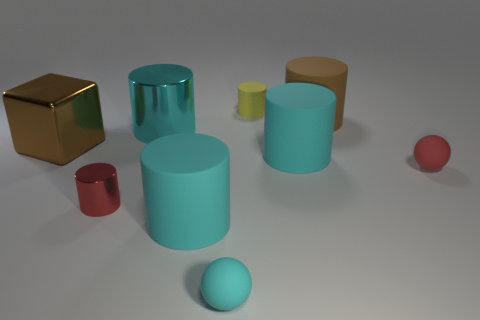Subtract all cylinders. How many objects are left? 3 Subtract all big shiny cylinders. How many cylinders are left? 5 Subtract 0 purple cylinders. How many objects are left? 9 Subtract 1 spheres. How many spheres are left? 1 Subtract all purple cylinders. Subtract all green cubes. How many cylinders are left? 6 Subtract all brown cylinders. How many cyan blocks are left? 0 Subtract all yellow matte things. Subtract all cyan rubber spheres. How many objects are left? 7 Add 7 big rubber cylinders. How many big rubber cylinders are left? 10 Add 5 yellow rubber objects. How many yellow rubber objects exist? 6 Subtract all red cylinders. How many cylinders are left? 5 